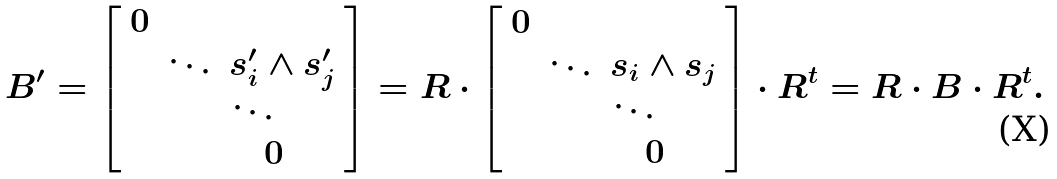<formula> <loc_0><loc_0><loc_500><loc_500>B ^ { \prime } = \left [ \begin{array} { c c l } 0 & & \\ & \ddots & s ^ { \prime } _ { i } \wedge s ^ { \prime } _ { j } \\ & & \ddots \\ & & \quad 0 \end{array} \right ] = R \cdot \left [ \begin{array} { c c l } 0 & & \\ & \ddots & s _ { i } \wedge s _ { j } \\ & & \ddots \\ & & \quad 0 \end{array} \right ] \cdot R ^ { t } = R \cdot B \cdot R ^ { t } .</formula> 